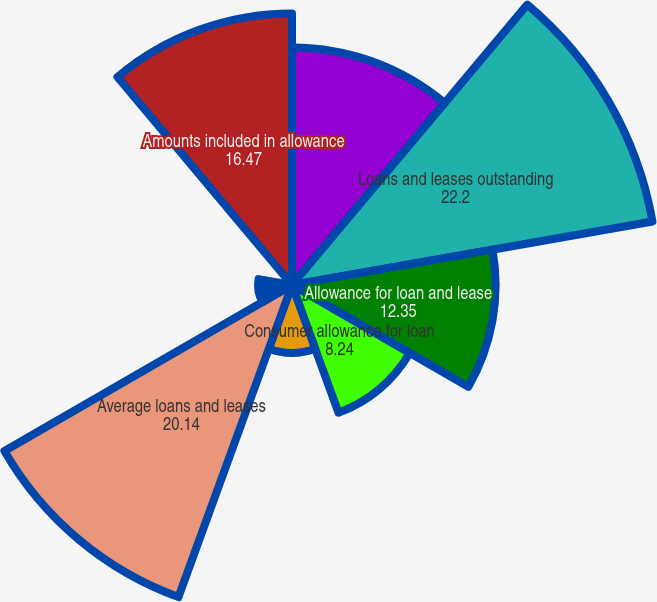<chart> <loc_0><loc_0><loc_500><loc_500><pie_chart><fcel>(Dollars in millions)<fcel>Loans and leases outstanding<fcel>Allowance for loan and lease<fcel>Consumer allowance for loan<fcel>Commercial allowance for loan<fcel>Average loans and leases<fcel>Net charge-offs as a<fcel>Ratio of the allowance for<fcel>Amounts included in allowance<nl><fcel>14.41%<fcel>22.2%<fcel>12.35%<fcel>8.24%<fcel>4.12%<fcel>20.14%<fcel>2.06%<fcel>0.0%<fcel>16.47%<nl></chart> 